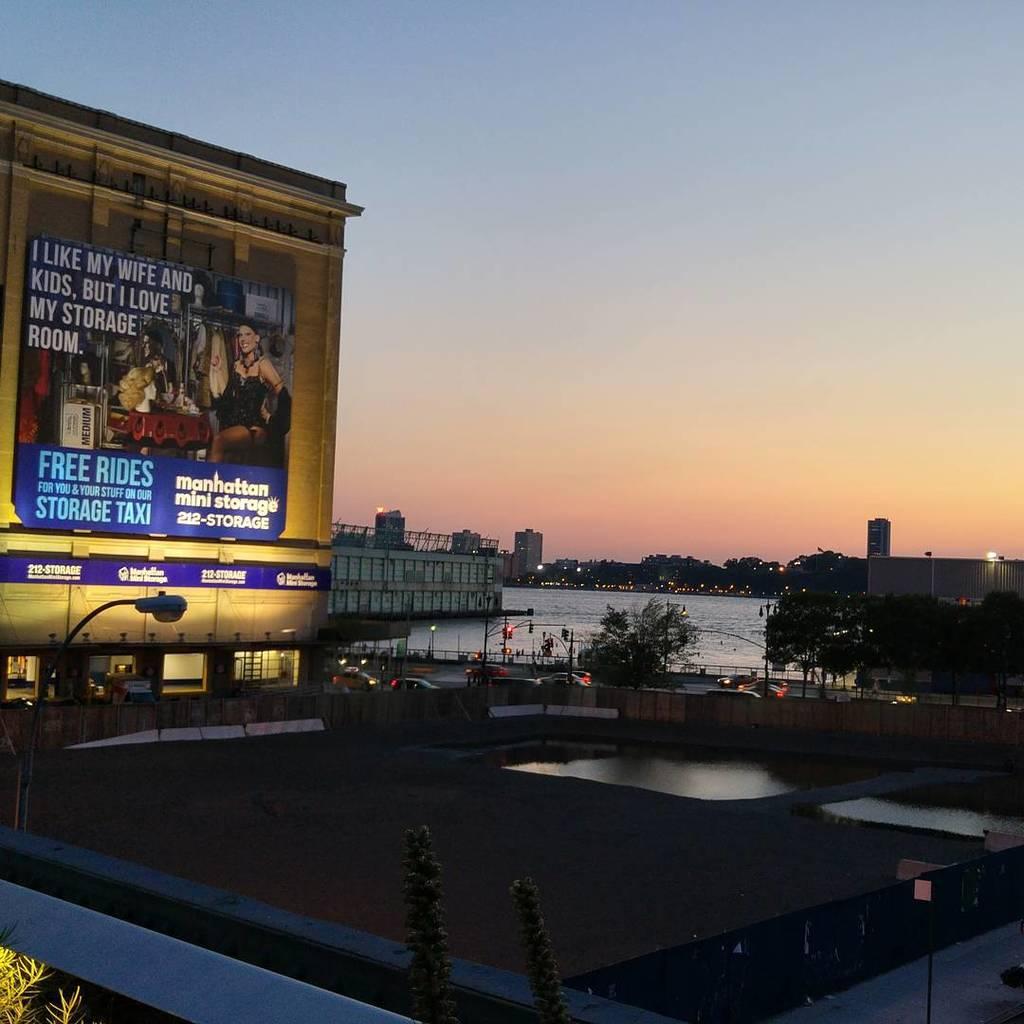What does the advertisement compare storage room to liking?
Keep it short and to the point. Wife and kids. 